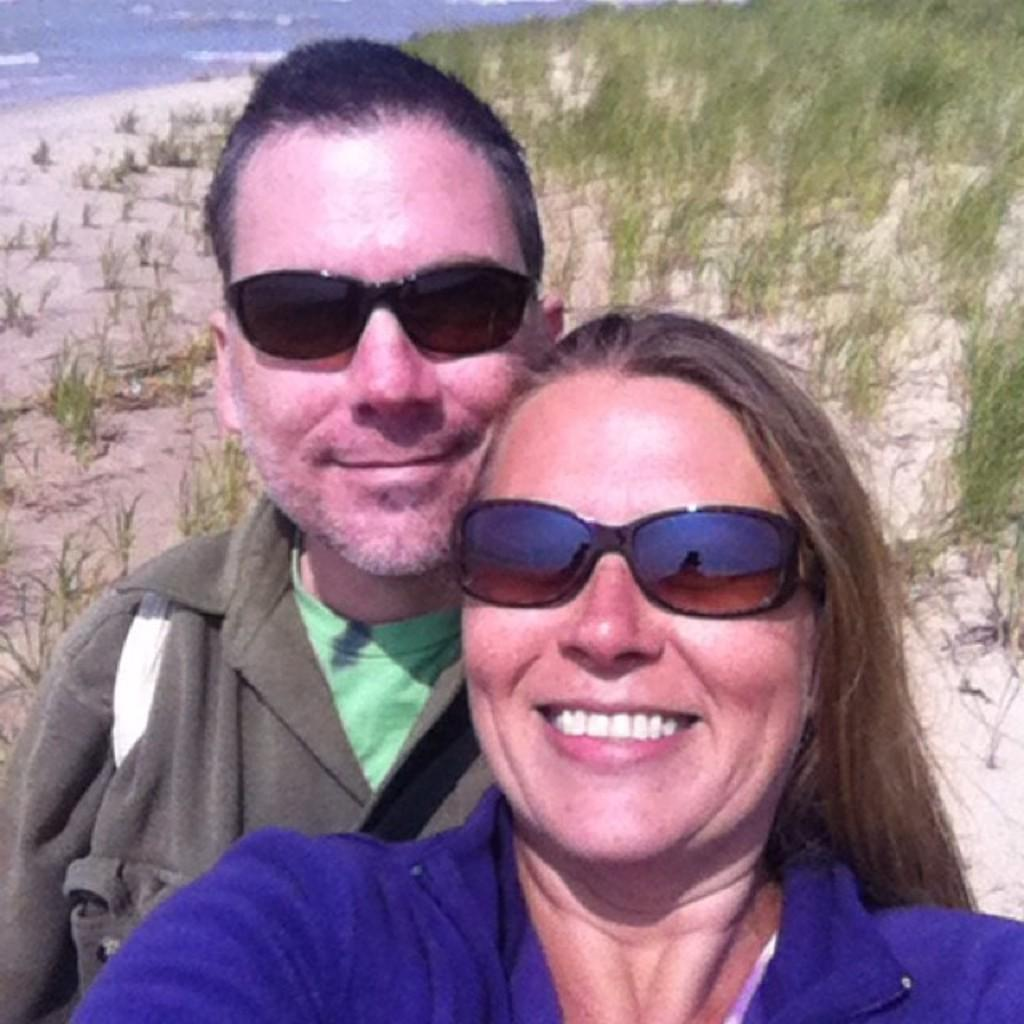How many people are in the image? There are two persons in the image. What is the facial expression of the persons in the image? The persons are smiling. What type of terrain can be seen in the image? There is grass, sand, and water in the image. What type of pencil can be seen in the image? There is no pencil present in the image. What kind of plantation is visible in the image? There is no plantation present in the image. Can you tell me how many donkeys are in the image? There are no donkeys present in the image. 